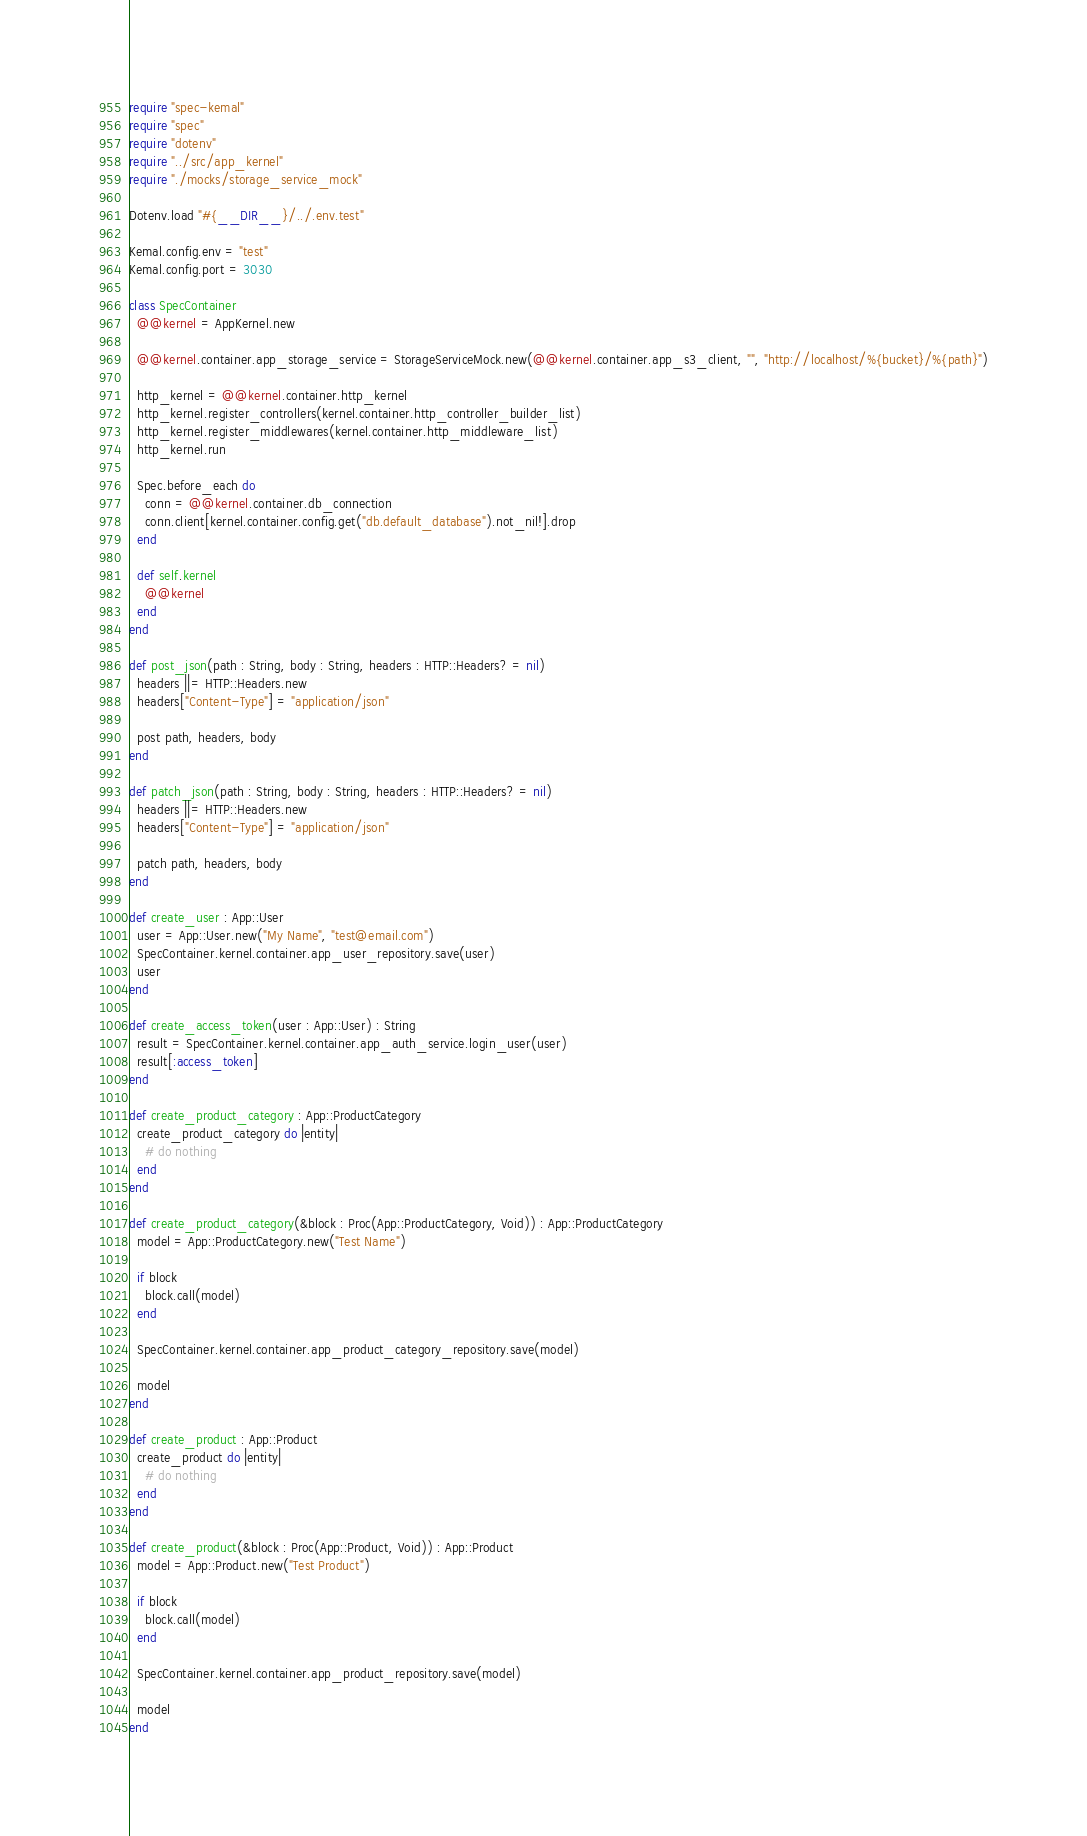<code> <loc_0><loc_0><loc_500><loc_500><_Crystal_>require "spec-kemal"
require "spec"
require "dotenv"
require "../src/app_kernel"
require "./mocks/storage_service_mock"

Dotenv.load "#{__DIR__}/../.env.test"

Kemal.config.env = "test"
Kemal.config.port = 3030

class SpecContainer
  @@kernel = AppKernel.new

  @@kernel.container.app_storage_service = StorageServiceMock.new(@@kernel.container.app_s3_client, "", "http://localhost/%{bucket}/%{path}")

  http_kernel = @@kernel.container.http_kernel
  http_kernel.register_controllers(kernel.container.http_controller_builder_list)
  http_kernel.register_middlewares(kernel.container.http_middleware_list)
  http_kernel.run

  Spec.before_each do
    conn = @@kernel.container.db_connection
    conn.client[kernel.container.config.get("db.default_database").not_nil!].drop
  end

  def self.kernel
    @@kernel
  end
end

def post_json(path : String, body : String, headers : HTTP::Headers? = nil)
  headers ||= HTTP::Headers.new
  headers["Content-Type"] = "application/json"

  post path, headers, body
end

def patch_json(path : String, body : String, headers : HTTP::Headers? = nil)
  headers ||= HTTP::Headers.new
  headers["Content-Type"] = "application/json"

  patch path, headers, body
end

def create_user : App::User
  user = App::User.new("My Name", "test@email.com")
  SpecContainer.kernel.container.app_user_repository.save(user)
  user
end

def create_access_token(user : App::User) : String
  result = SpecContainer.kernel.container.app_auth_service.login_user(user)
  result[:access_token]
end

def create_product_category : App::ProductCategory
  create_product_category do |entity|
    # do nothing
  end
end

def create_product_category(&block : Proc(App::ProductCategory, Void)) : App::ProductCategory
  model = App::ProductCategory.new("Test Name")

  if block
    block.call(model)
  end

  SpecContainer.kernel.container.app_product_category_repository.save(model)

  model
end

def create_product : App::Product
  create_product do |entity|
    # do nothing
  end
end

def create_product(&block : Proc(App::Product, Void)) : App::Product
  model = App::Product.new("Test Product")

  if block
    block.call(model)
  end

  SpecContainer.kernel.container.app_product_repository.save(model)

  model
end
</code> 